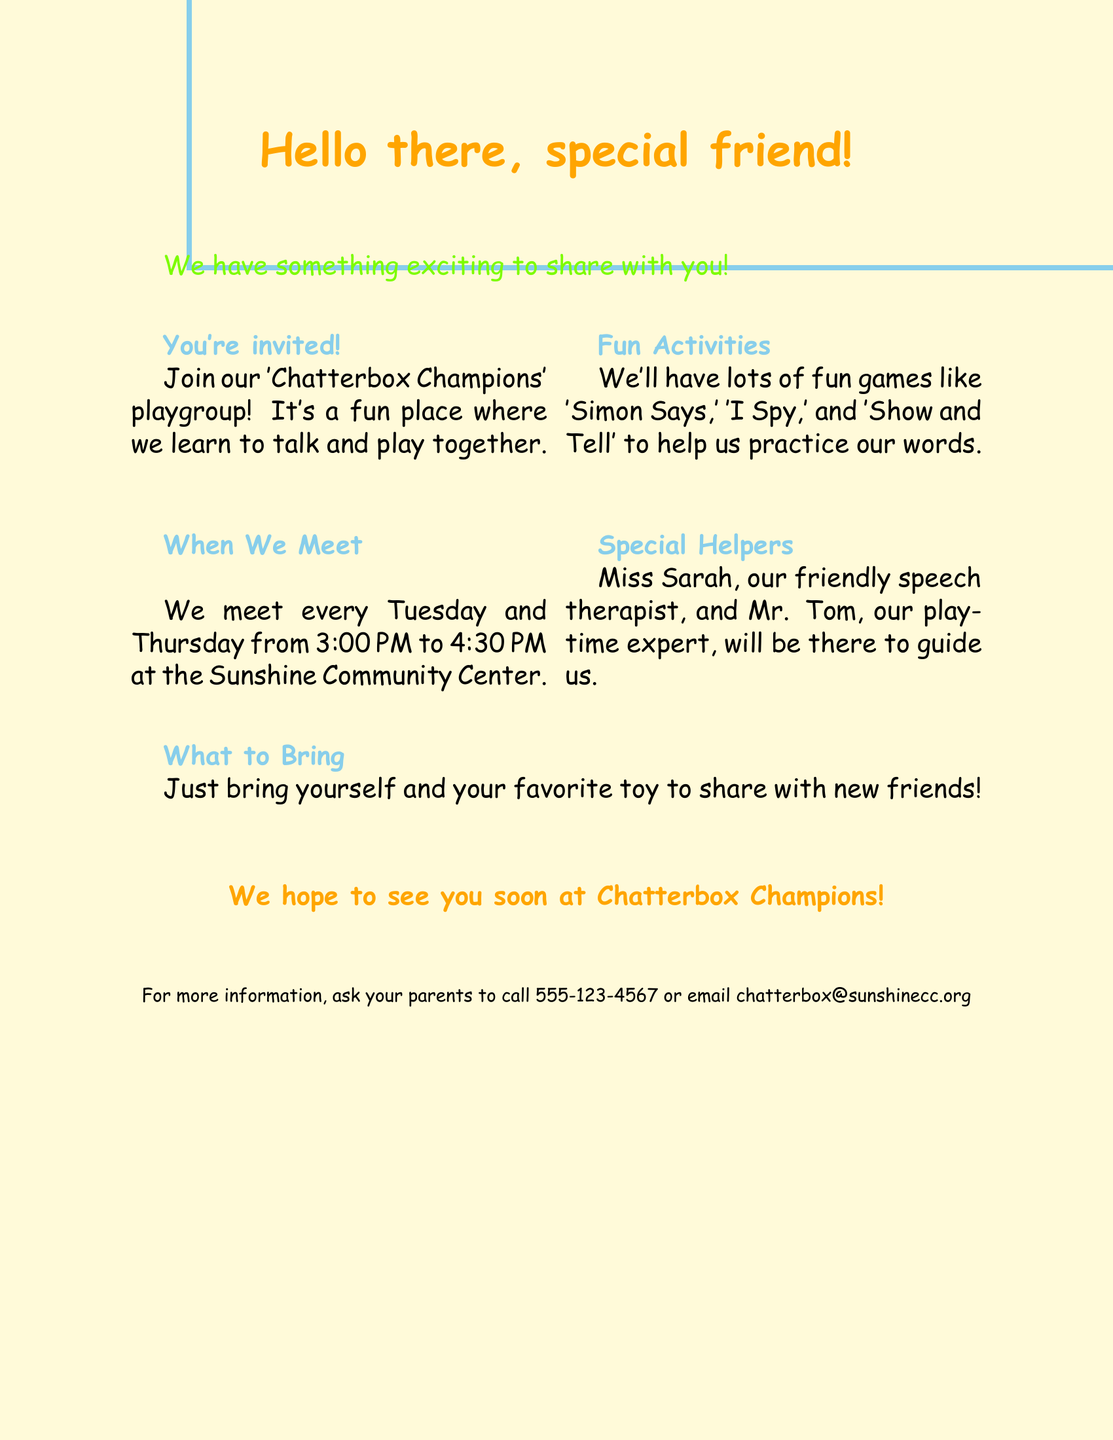What is the name of the playgroup? The name of the playgroup is mentioned in the invitation section of the document.
Answer: Chatterbox Champions When do the meetings take place? The document states the specific days and time for the meetings in the schedule section.
Answer: Tuesday and Thursday from 3:00 PM to 4:30 PM Who are the special helpers? The names of the special helpers are found in the special helpers section of the document.
Answer: Miss Sarah and Mr. Tom What should you bring to the playgroup? The document specifies what to bring in the 'What to Bring' section.
Answer: Yourself and your favorite toy What kind of games will we play? The document lists specific games in the activities section.
Answer: 'Simon Says,' 'I Spy,' and 'Show and Tell' What is the color scheme of the document? The document includes a specified color scheme, which is stated in the visual elements section.
Answer: Bright Yellow, Sky Blue, Grass Green, Sunshine Orange 